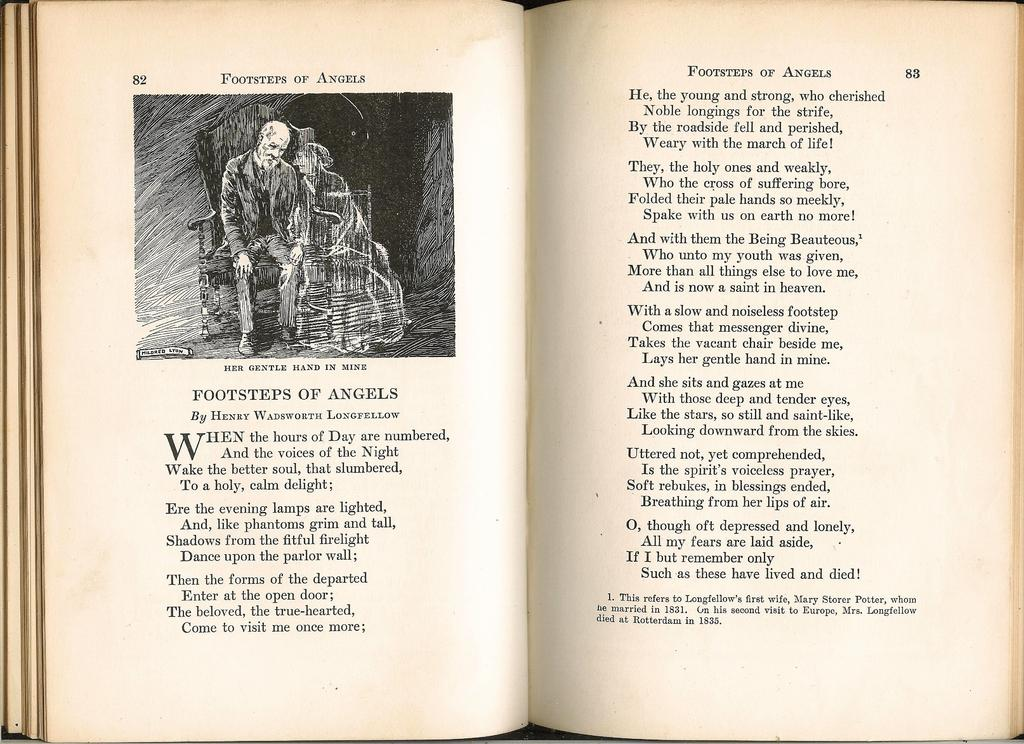<image>
Describe the image concisely. A book is open to page eighty two and eight three. 